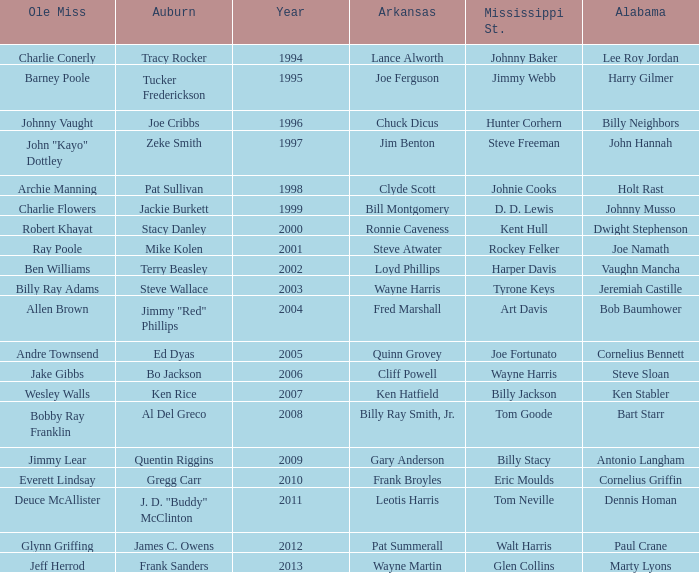Who was the Alabama player associated with Walt Harris? Paul Crane. 